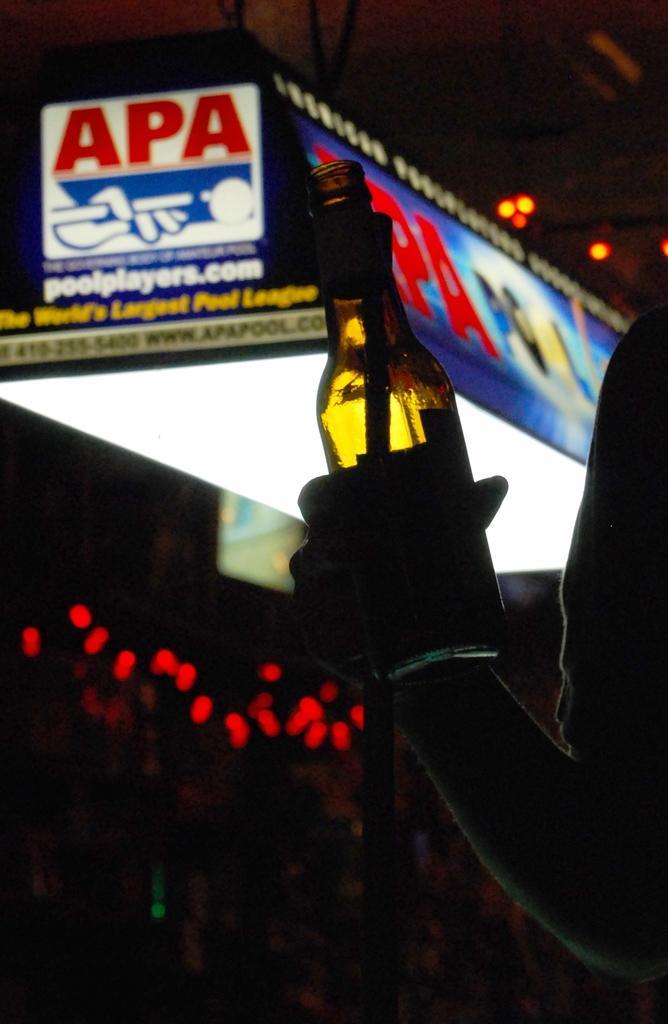Describe this image in one or two sentences. I can see in this image a person is holding a glass bottle in his hand. In the background I can see a board. 